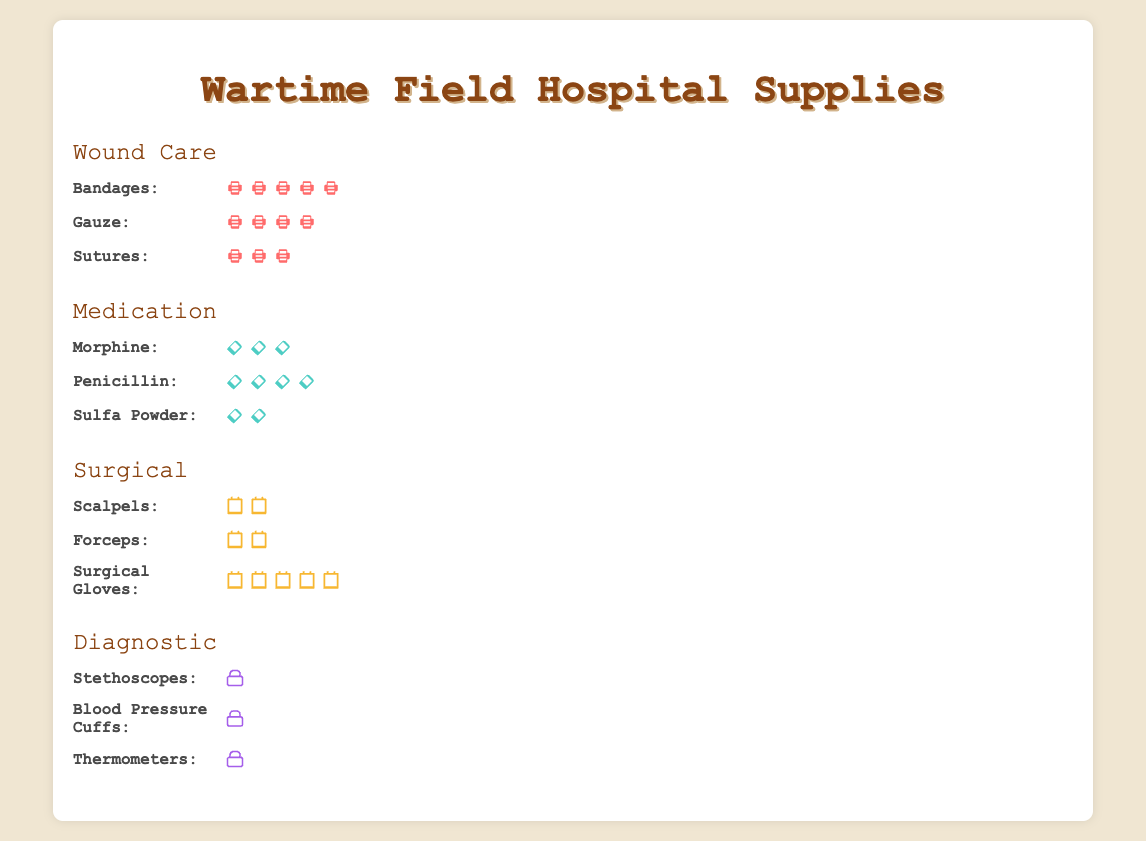How many categories of medical supplies are there? The figure shows four distinct categories of medical supplies, each with a label: Wound Care, Medication, Surgical, and Diagnostic. By counting these labels, we identify four unique categories.
Answer: 4 Which category uses the highest number of Bandages? Focusing on the "Wound Care" category, the Bandages row displays a total of 50 bandage icons. Comparing it to the other categories, 50 bandages are the most for any single supply type in the entire figure.
Answer: Wound Care How many types of supplies are listed under 'Medication'? Analyzing the 'Medication' category, we see three supply types: Morphine, Penicillin, and Sulfa Powder. Counting these, we can confirm there are three types of supplies under 'Medication'.
Answer: 3 Which category has the least amount of supplies in total? Summing up the supplies in each category:
- Wound Care: 50 + 40 + 30 = 120
- Medication: 25 + 35 + 20 = 80
- Surgical: 15 + 20 + 45 = 80
- Diagnostic: 10 + 8 + 12 = 30
Diagnostic has the least total supplies.
Answer: Diagnostic Do 'Sutures' outnumber 'Forceps'? If so, by how much? Sutures (in Wound Care) have a total count of 30, while Forceps (in Surgical) have a count of 20. The difference between them is 30 - 20 = 10.
Answer: Yes, by 10 Which supply is most common in the 'Surgical' category? Reviewing the 'Surgical' category, Surgical Gloves have 45 icons, Scalpels have 15, and Forceps have 20. Surgical Gloves are the most common with 45 icons.
Answer: Surgical Gloves How many more Bandages than Thermometers are there? Bandages (Wound Care) have a count of 50, and Thermometers (Diagnostic) have a count of 12. The difference is 50 - 12 = 38.
Answer: 38 What is the total number of supplies in the 'Wound Care' category? Adding up the supplies in the 'Wound Care' category: Bandages (50), Gauze (40), and Sutures (30), giving us a total of 50 + 40 + 30 = 120.
Answer: 120 